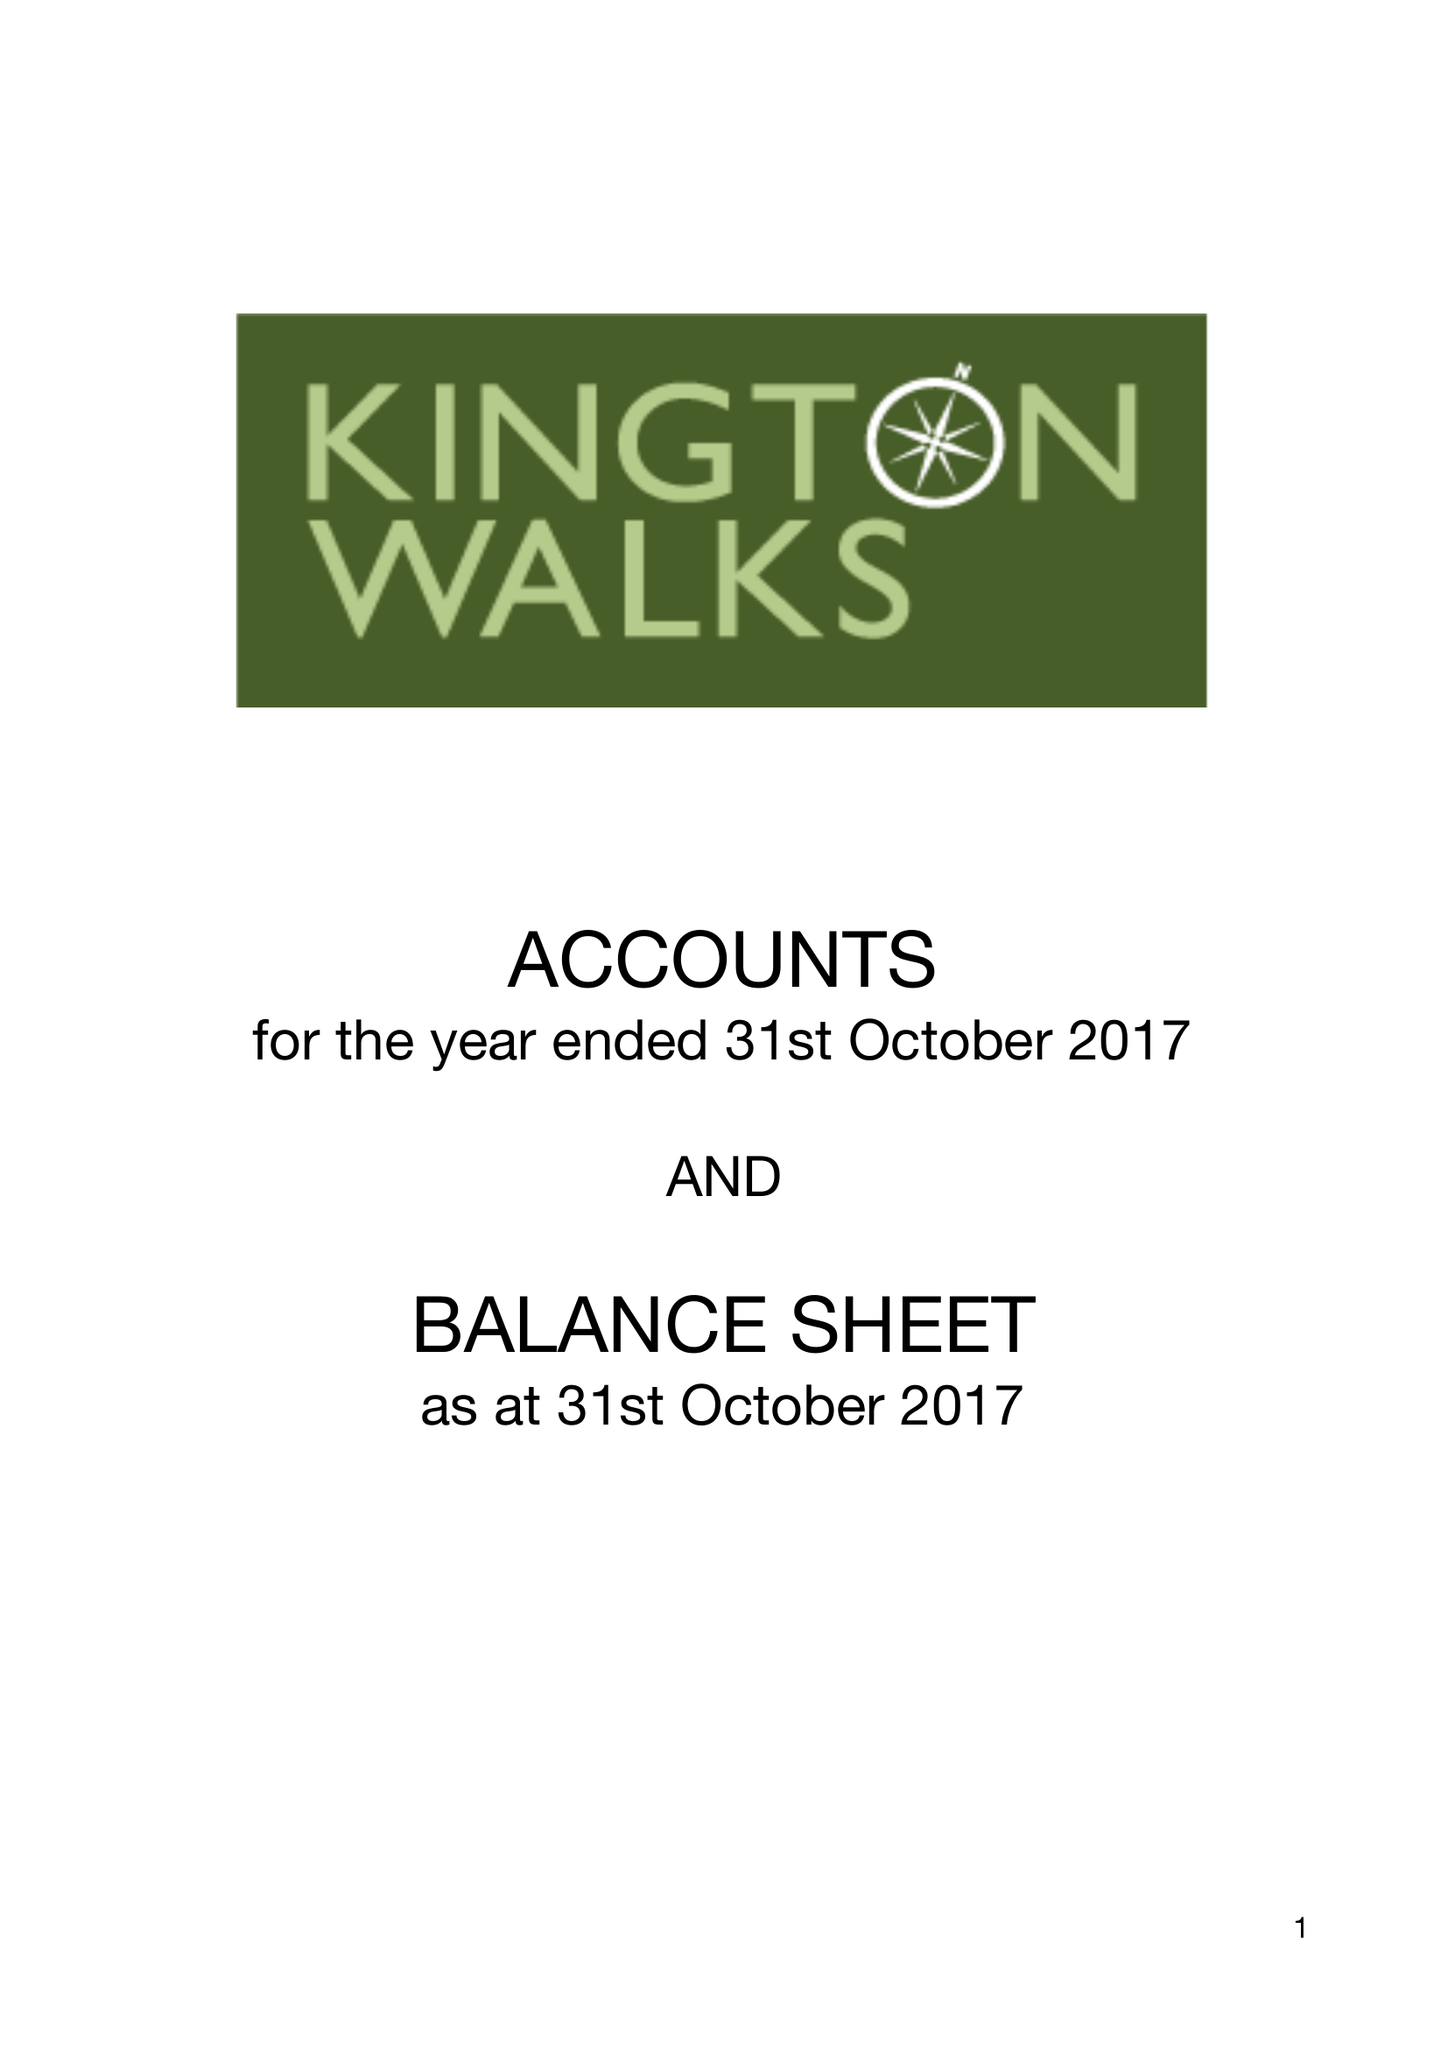What is the value for the address__postcode?
Answer the question using a single word or phrase. HR5 3HJ 